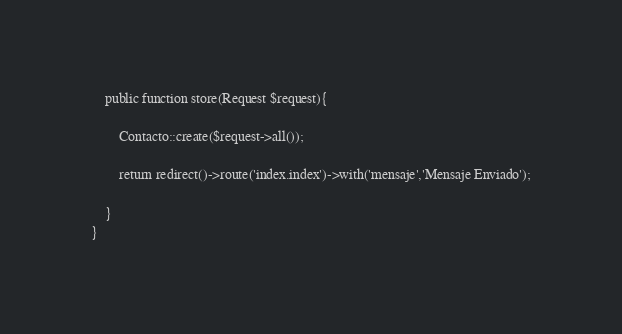<code> <loc_0><loc_0><loc_500><loc_500><_PHP_>    public function store(Request $request){

        Contacto::create($request->all());

        return redirect()->route('index.index')->with('mensaje','Mensaje Enviado');

    }
}
</code> 